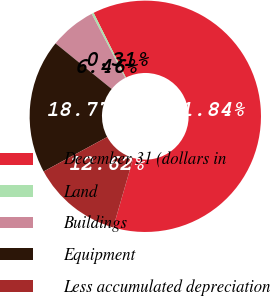<chart> <loc_0><loc_0><loc_500><loc_500><pie_chart><fcel>December 31 (dollars in<fcel>Land<fcel>Buildings<fcel>Equipment<fcel>Less accumulated depreciation<nl><fcel>61.84%<fcel>0.31%<fcel>6.46%<fcel>18.77%<fcel>12.62%<nl></chart> 